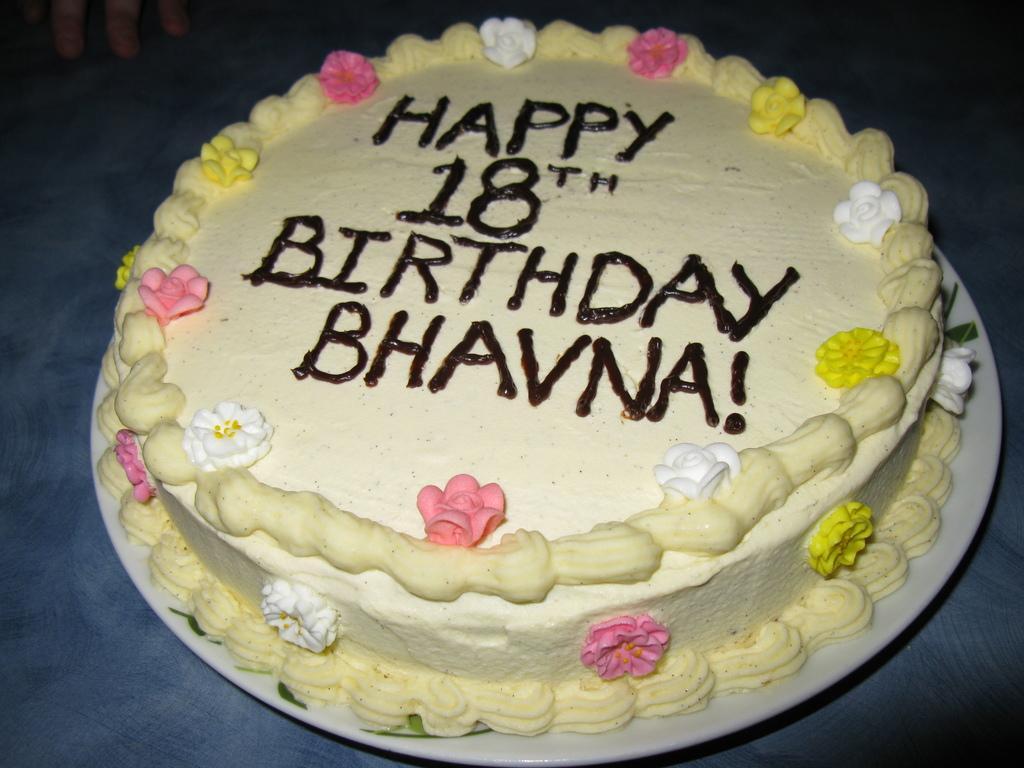In one or two sentences, can you explain what this image depicts? This is a zoomed in picture. In the center we can see a white color palette containing the birthday cake and we can see the text and numbers on the cake and the platter is placed on the top of the table. In the background we can see the fingers of the person. 